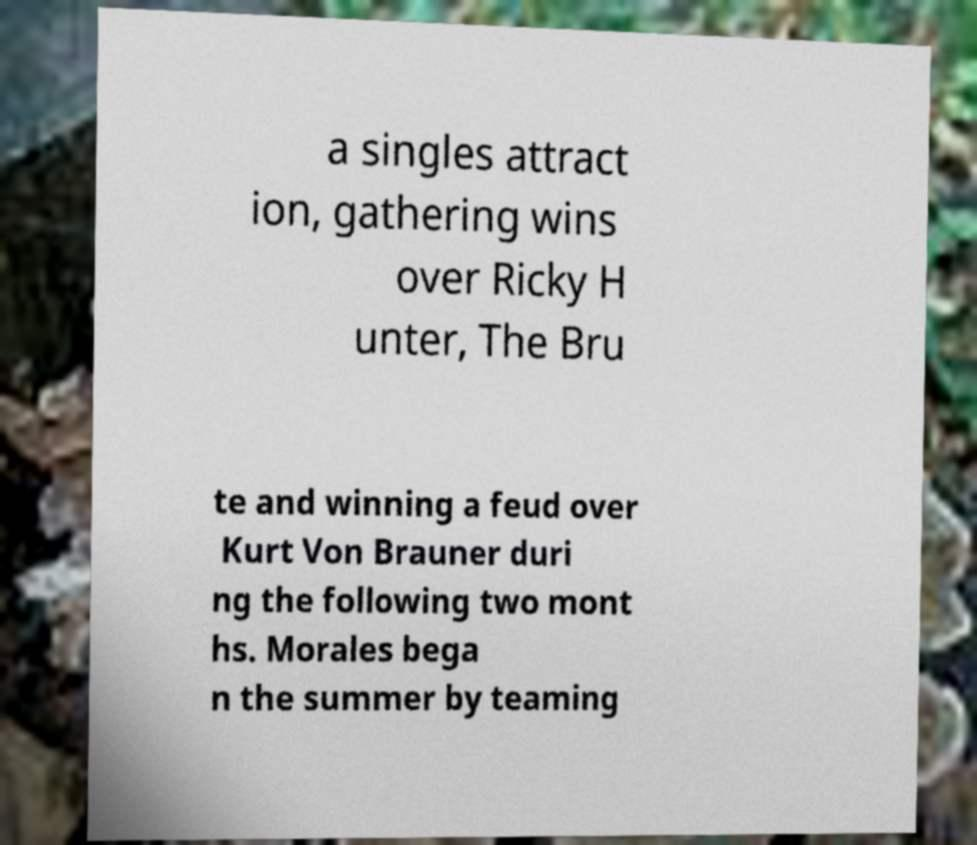Could you assist in decoding the text presented in this image and type it out clearly? a singles attract ion, gathering wins over Ricky H unter, The Bru te and winning a feud over Kurt Von Brauner duri ng the following two mont hs. Morales bega n the summer by teaming 